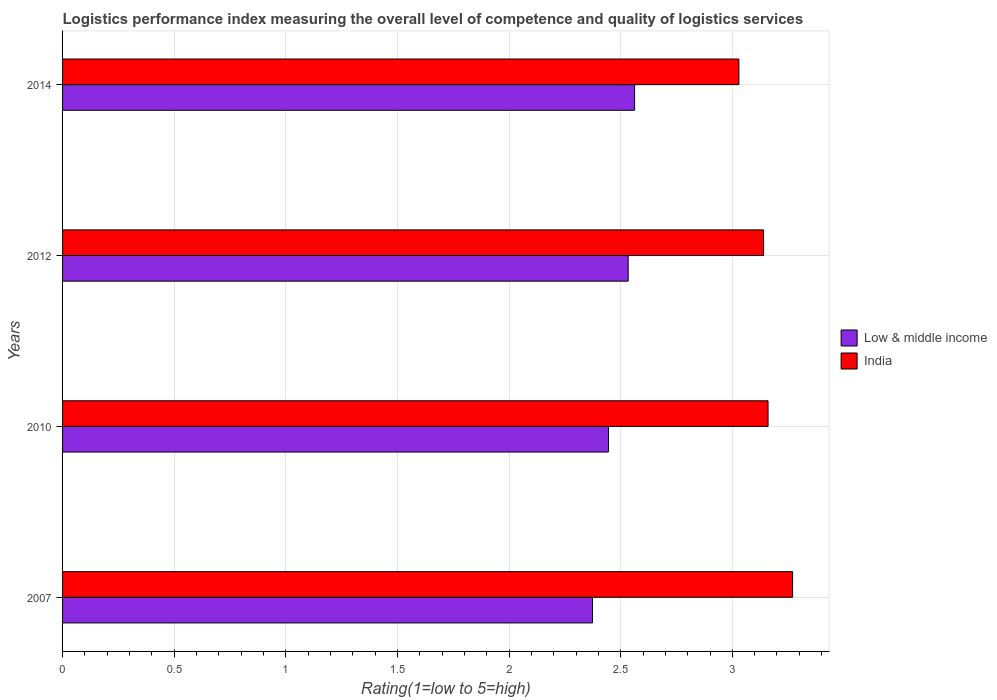Are the number of bars on each tick of the Y-axis equal?
Keep it short and to the point. Yes. How many bars are there on the 2nd tick from the top?
Make the answer very short. 2. How many bars are there on the 2nd tick from the bottom?
Ensure brevity in your answer.  2. What is the Logistic performance index in India in 2012?
Your answer should be compact. 3.14. Across all years, what is the maximum Logistic performance index in India?
Keep it short and to the point. 3.27. Across all years, what is the minimum Logistic performance index in Low & middle income?
Provide a short and direct response. 2.37. In which year was the Logistic performance index in Low & middle income maximum?
Make the answer very short. 2014. In which year was the Logistic performance index in Low & middle income minimum?
Offer a very short reply. 2007. What is the total Logistic performance index in India in the graph?
Make the answer very short. 12.6. What is the difference between the Logistic performance index in India in 2007 and that in 2012?
Offer a very short reply. 0.13. What is the difference between the Logistic performance index in India in 2010 and the Logistic performance index in Low & middle income in 2007?
Offer a terse response. 0.79. What is the average Logistic performance index in Low & middle income per year?
Give a very brief answer. 2.48. In the year 2010, what is the difference between the Logistic performance index in Low & middle income and Logistic performance index in India?
Offer a very short reply. -0.71. In how many years, is the Logistic performance index in Low & middle income greater than 0.4 ?
Give a very brief answer. 4. What is the ratio of the Logistic performance index in Low & middle income in 2007 to that in 2010?
Provide a short and direct response. 0.97. Is the Logistic performance index in India in 2010 less than that in 2012?
Your answer should be compact. No. Is the difference between the Logistic performance index in Low & middle income in 2007 and 2010 greater than the difference between the Logistic performance index in India in 2007 and 2010?
Your response must be concise. No. What is the difference between the highest and the second highest Logistic performance index in Low & middle income?
Give a very brief answer. 0.03. What is the difference between the highest and the lowest Logistic performance index in Low & middle income?
Make the answer very short. 0.19. In how many years, is the Logistic performance index in Low & middle income greater than the average Logistic performance index in Low & middle income taken over all years?
Give a very brief answer. 2. Is the sum of the Logistic performance index in India in 2010 and 2014 greater than the maximum Logistic performance index in Low & middle income across all years?
Offer a terse response. Yes. What does the 1st bar from the top in 2007 represents?
Make the answer very short. India. What does the 2nd bar from the bottom in 2012 represents?
Ensure brevity in your answer.  India. How many bars are there?
Keep it short and to the point. 8. Are all the bars in the graph horizontal?
Offer a very short reply. Yes. Does the graph contain any zero values?
Keep it short and to the point. No. Does the graph contain grids?
Keep it short and to the point. Yes. Where does the legend appear in the graph?
Your answer should be compact. Center right. How many legend labels are there?
Your answer should be compact. 2. How are the legend labels stacked?
Offer a terse response. Vertical. What is the title of the graph?
Your answer should be compact. Logistics performance index measuring the overall level of competence and quality of logistics services. Does "Latvia" appear as one of the legend labels in the graph?
Provide a short and direct response. No. What is the label or title of the X-axis?
Give a very brief answer. Rating(1=low to 5=high). What is the Rating(1=low to 5=high) in Low & middle income in 2007?
Your answer should be compact. 2.37. What is the Rating(1=low to 5=high) of India in 2007?
Keep it short and to the point. 3.27. What is the Rating(1=low to 5=high) of Low & middle income in 2010?
Provide a short and direct response. 2.45. What is the Rating(1=low to 5=high) in India in 2010?
Provide a short and direct response. 3.16. What is the Rating(1=low to 5=high) in Low & middle income in 2012?
Make the answer very short. 2.53. What is the Rating(1=low to 5=high) in India in 2012?
Give a very brief answer. 3.14. What is the Rating(1=low to 5=high) in Low & middle income in 2014?
Your response must be concise. 2.56. What is the Rating(1=low to 5=high) of India in 2014?
Make the answer very short. 3.03. Across all years, what is the maximum Rating(1=low to 5=high) of Low & middle income?
Your answer should be compact. 2.56. Across all years, what is the maximum Rating(1=low to 5=high) of India?
Keep it short and to the point. 3.27. Across all years, what is the minimum Rating(1=low to 5=high) of Low & middle income?
Provide a succinct answer. 2.37. Across all years, what is the minimum Rating(1=low to 5=high) in India?
Keep it short and to the point. 3.03. What is the total Rating(1=low to 5=high) of Low & middle income in the graph?
Your answer should be very brief. 9.91. What is the total Rating(1=low to 5=high) of India in the graph?
Keep it short and to the point. 12.6. What is the difference between the Rating(1=low to 5=high) in Low & middle income in 2007 and that in 2010?
Keep it short and to the point. -0.07. What is the difference between the Rating(1=low to 5=high) of India in 2007 and that in 2010?
Give a very brief answer. 0.11. What is the difference between the Rating(1=low to 5=high) in Low & middle income in 2007 and that in 2012?
Your answer should be very brief. -0.16. What is the difference between the Rating(1=low to 5=high) of India in 2007 and that in 2012?
Your answer should be very brief. 0.13. What is the difference between the Rating(1=low to 5=high) in Low & middle income in 2007 and that in 2014?
Give a very brief answer. -0.19. What is the difference between the Rating(1=low to 5=high) in India in 2007 and that in 2014?
Provide a short and direct response. 0.24. What is the difference between the Rating(1=low to 5=high) in Low & middle income in 2010 and that in 2012?
Your response must be concise. -0.09. What is the difference between the Rating(1=low to 5=high) of Low & middle income in 2010 and that in 2014?
Provide a short and direct response. -0.12. What is the difference between the Rating(1=low to 5=high) of India in 2010 and that in 2014?
Your response must be concise. 0.13. What is the difference between the Rating(1=low to 5=high) of Low & middle income in 2012 and that in 2014?
Provide a succinct answer. -0.03. What is the difference between the Rating(1=low to 5=high) in India in 2012 and that in 2014?
Offer a very short reply. 0.11. What is the difference between the Rating(1=low to 5=high) of Low & middle income in 2007 and the Rating(1=low to 5=high) of India in 2010?
Provide a succinct answer. -0.79. What is the difference between the Rating(1=low to 5=high) of Low & middle income in 2007 and the Rating(1=low to 5=high) of India in 2012?
Ensure brevity in your answer.  -0.77. What is the difference between the Rating(1=low to 5=high) in Low & middle income in 2007 and the Rating(1=low to 5=high) in India in 2014?
Your answer should be compact. -0.66. What is the difference between the Rating(1=low to 5=high) in Low & middle income in 2010 and the Rating(1=low to 5=high) in India in 2012?
Make the answer very short. -0.69. What is the difference between the Rating(1=low to 5=high) of Low & middle income in 2010 and the Rating(1=low to 5=high) of India in 2014?
Your response must be concise. -0.58. What is the difference between the Rating(1=low to 5=high) in Low & middle income in 2012 and the Rating(1=low to 5=high) in India in 2014?
Make the answer very short. -0.5. What is the average Rating(1=low to 5=high) in Low & middle income per year?
Your answer should be very brief. 2.48. What is the average Rating(1=low to 5=high) of India per year?
Keep it short and to the point. 3.15. In the year 2007, what is the difference between the Rating(1=low to 5=high) of Low & middle income and Rating(1=low to 5=high) of India?
Your response must be concise. -0.9. In the year 2010, what is the difference between the Rating(1=low to 5=high) in Low & middle income and Rating(1=low to 5=high) in India?
Offer a terse response. -0.71. In the year 2012, what is the difference between the Rating(1=low to 5=high) of Low & middle income and Rating(1=low to 5=high) of India?
Your answer should be very brief. -0.61. In the year 2014, what is the difference between the Rating(1=low to 5=high) of Low & middle income and Rating(1=low to 5=high) of India?
Ensure brevity in your answer.  -0.47. What is the ratio of the Rating(1=low to 5=high) of Low & middle income in 2007 to that in 2010?
Give a very brief answer. 0.97. What is the ratio of the Rating(1=low to 5=high) of India in 2007 to that in 2010?
Ensure brevity in your answer.  1.03. What is the ratio of the Rating(1=low to 5=high) of Low & middle income in 2007 to that in 2012?
Ensure brevity in your answer.  0.94. What is the ratio of the Rating(1=low to 5=high) in India in 2007 to that in 2012?
Give a very brief answer. 1.04. What is the ratio of the Rating(1=low to 5=high) of Low & middle income in 2007 to that in 2014?
Offer a very short reply. 0.93. What is the ratio of the Rating(1=low to 5=high) in India in 2007 to that in 2014?
Offer a very short reply. 1.08. What is the ratio of the Rating(1=low to 5=high) in Low & middle income in 2010 to that in 2012?
Provide a succinct answer. 0.97. What is the ratio of the Rating(1=low to 5=high) in India in 2010 to that in 2012?
Keep it short and to the point. 1.01. What is the ratio of the Rating(1=low to 5=high) in Low & middle income in 2010 to that in 2014?
Provide a succinct answer. 0.95. What is the ratio of the Rating(1=low to 5=high) of India in 2010 to that in 2014?
Provide a succinct answer. 1.04. What is the ratio of the Rating(1=low to 5=high) of India in 2012 to that in 2014?
Keep it short and to the point. 1.04. What is the difference between the highest and the second highest Rating(1=low to 5=high) of Low & middle income?
Your response must be concise. 0.03. What is the difference between the highest and the second highest Rating(1=low to 5=high) of India?
Your answer should be very brief. 0.11. What is the difference between the highest and the lowest Rating(1=low to 5=high) of Low & middle income?
Provide a succinct answer. 0.19. What is the difference between the highest and the lowest Rating(1=low to 5=high) in India?
Offer a terse response. 0.24. 